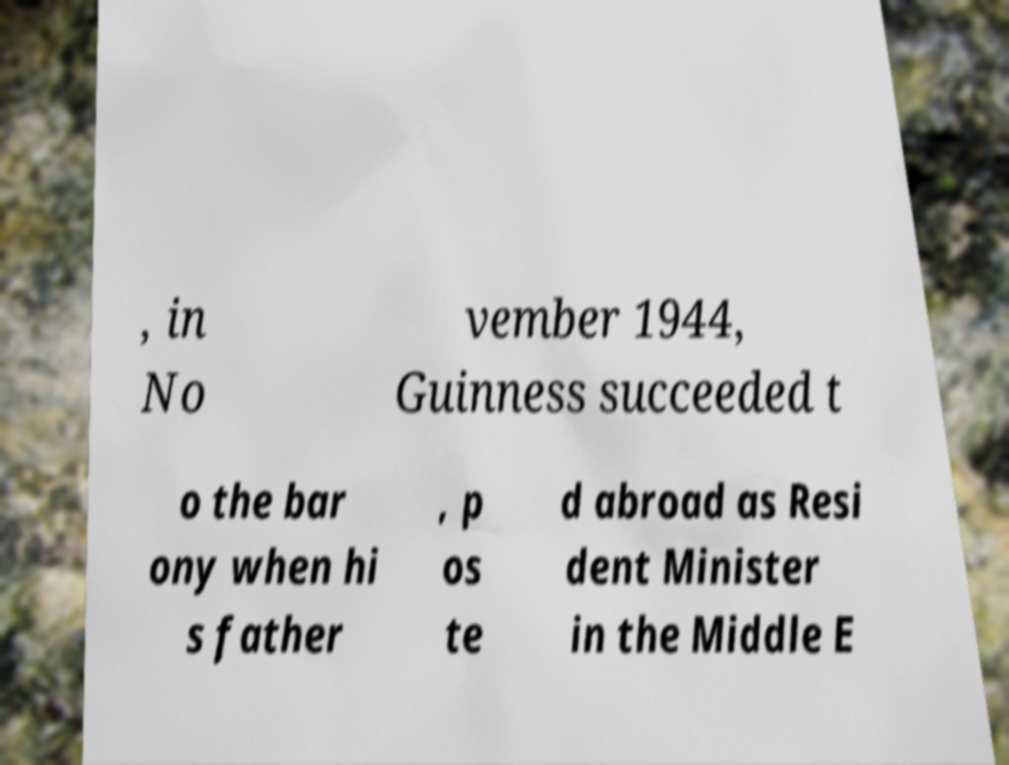I need the written content from this picture converted into text. Can you do that? , in No vember 1944, Guinness succeeded t o the bar ony when hi s father , p os te d abroad as Resi dent Minister in the Middle E 